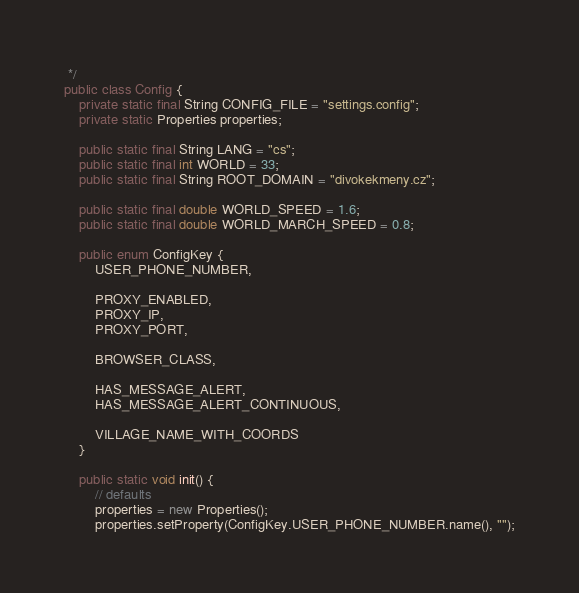Convert code to text. <code><loc_0><loc_0><loc_500><loc_500><_Java_> */
public class Config {
    private static final String CONFIG_FILE = "settings.config";
    private static Properties properties;
    
    public static final String LANG = "cs";
    public static final int WORLD = 33;
    public static final String ROOT_DOMAIN = "divokekmeny.cz";
    
    public static final double WORLD_SPEED = 1.6;
    public static final double WORLD_MARCH_SPEED = 0.8;
    
    public enum ConfigKey {
        USER_PHONE_NUMBER,
        
        PROXY_ENABLED,
        PROXY_IP,
        PROXY_PORT, 
        
        BROWSER_CLASS,
        
        HAS_MESSAGE_ALERT,
        HAS_MESSAGE_ALERT_CONTINUOUS,
        
        VILLAGE_NAME_WITH_COORDS
    }
    
    public static void init() {
        // defaults
        properties = new Properties();
        properties.setProperty(ConfigKey.USER_PHONE_NUMBER.name(), "");</code> 